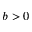<formula> <loc_0><loc_0><loc_500><loc_500>b > 0</formula> 